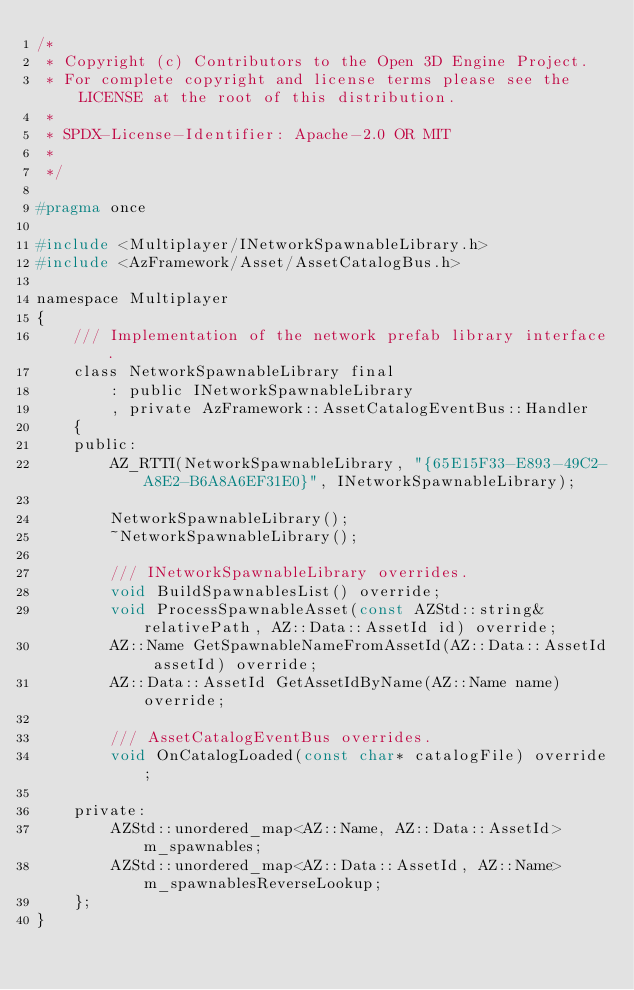Convert code to text. <code><loc_0><loc_0><loc_500><loc_500><_C_>/*
 * Copyright (c) Contributors to the Open 3D Engine Project.
 * For complete copyright and license terms please see the LICENSE at the root of this distribution.
 *
 * SPDX-License-Identifier: Apache-2.0 OR MIT
 *
 */

#pragma once

#include <Multiplayer/INetworkSpawnableLibrary.h>
#include <AzFramework/Asset/AssetCatalogBus.h>

namespace Multiplayer
{
    /// Implementation of the network prefab library interface.
    class NetworkSpawnableLibrary final
        : public INetworkSpawnableLibrary
        , private AzFramework::AssetCatalogEventBus::Handler
    {
    public:
        AZ_RTTI(NetworkSpawnableLibrary, "{65E15F33-E893-49C2-A8E2-B6A8A6EF31E0}", INetworkSpawnableLibrary);

        NetworkSpawnableLibrary();
        ~NetworkSpawnableLibrary();

        /// INetworkSpawnableLibrary overrides.
        void BuildSpawnablesList() override;
        void ProcessSpawnableAsset(const AZStd::string& relativePath, AZ::Data::AssetId id) override;
        AZ::Name GetSpawnableNameFromAssetId(AZ::Data::AssetId assetId) override;
        AZ::Data::AssetId GetAssetIdByName(AZ::Name name) override;

        /// AssetCatalogEventBus overrides.
        void OnCatalogLoaded(const char* catalogFile) override;

    private:
        AZStd::unordered_map<AZ::Name, AZ::Data::AssetId> m_spawnables;
        AZStd::unordered_map<AZ::Data::AssetId, AZ::Name> m_spawnablesReverseLookup;
    };
}
</code> 